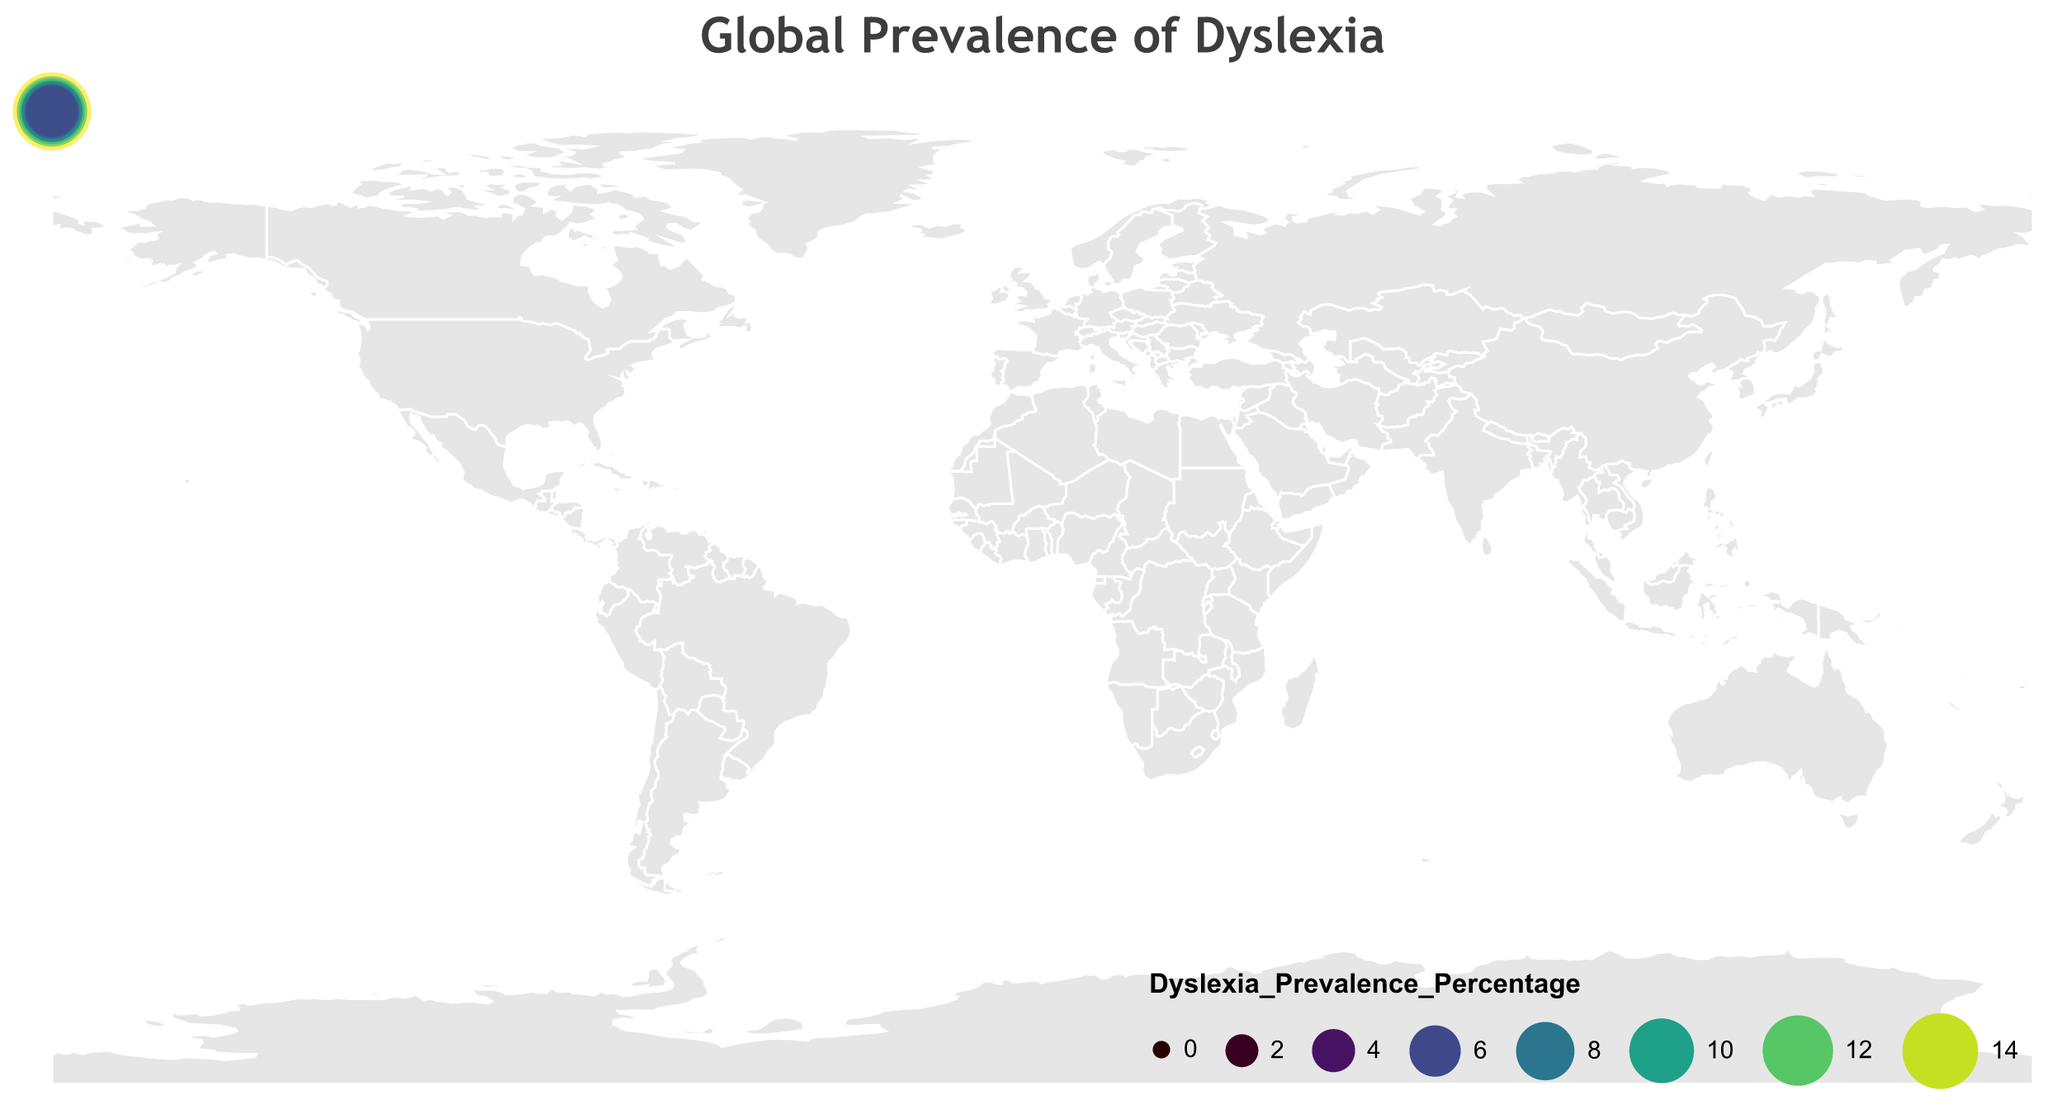What is the title of the figure? The title is written at the top of the figure, usually in a larger and bold font to distinguish it from the rest of the text.
Answer: "Global Prevalence of Dyslexia" Which country has the highest prevalence of dyslexia according to the figure? Look at the size and color of the circles representing each country. The largest and darkest circle indicates the highest prevalence.
Answer: United States How many countries have a prevalence rate of dyslexia above 10%? Identify and count the circles with a color and size indicating a prevalence rate above 10%. These should be labeled and easy to spot.
Answer: 3 (United States, United Kingdom, India) What is the prevalence of dyslexia in Canada, and how does it compare to that of Mexico? Look at the circles representing Canada and Mexico. Compare their sizes and colors to note both their individual values and their relationship. Canada has a prevalence of 8.0% and Mexico has 8.5%, so Mexico's rate is slightly higher.
Answer: Canada: 8.0%, Mexico: 8.5% Which country in Asia has the lowest dyslexia prevalence, and what is it? Identify the countries in Asia on the map. Check their circles' sizes and colors to find the lowest percentage.
Answer: China, 3.5% What is the average dyslexia prevalence rate of the European countries shown in the figure? List the European countries and their prevalence rates, then sum these before dividing by the number of countries. Countries: United Kingdom (10.0), Germany (5.0), France (6.5), Sweden (7.0), Italy (5.5), Spain (6.0), Netherlands (4.5), Russia (5.0), Norway (6.5), Finland (6.0). Sum = 10.0 + 5.0 + 6.5 + 7.0 + 5.5 + 6.0 + 4.5 + 5.0 + 6.5 + 6.0 = 62. Divide by 10 (number of countries): 62 / 10 = 6.2.
Answer: 6.2 Compare the prevalence rates of dyslexia between Japan and Australia. What do you observe? Look at the sizes and colors of the circles representing Japan and Australia. Japan has a prevalence of 4.0% and Australia has 10.5%. Australia has a significantly higher prevalence rate than Japan.
Answer: Japan: 4.0%, Australia: 10.5% What is the total prevalence rate of dyslexia for South American countries shown in the figure? Identify South American countries and sum their dyslexia prevalence rates. Countries: Brazil (7.5), Argentina (7.0). Sum: 7.5 + 7.0 = 14.5.
Answer: 14.5 What is the range of dyslexia prevalence rates observed in the figure? Identify the highest and lowest dyslexia prevalence percentages. The highest is 15.0% (United States) and the lowest is 3.5% (China). The range is calculated by subtracting the lowest value from the highest.
Answer: 11.5% (15.0 - 3.5) Which country in Africa is represented, and what is its dyslexia prevalence rate? Look for the circle on the African continent. It is labeled and easily identifiable.
Answer: South Africa, 9.0% 